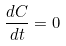<formula> <loc_0><loc_0><loc_500><loc_500>\frac { d C } { d t } = 0</formula> 